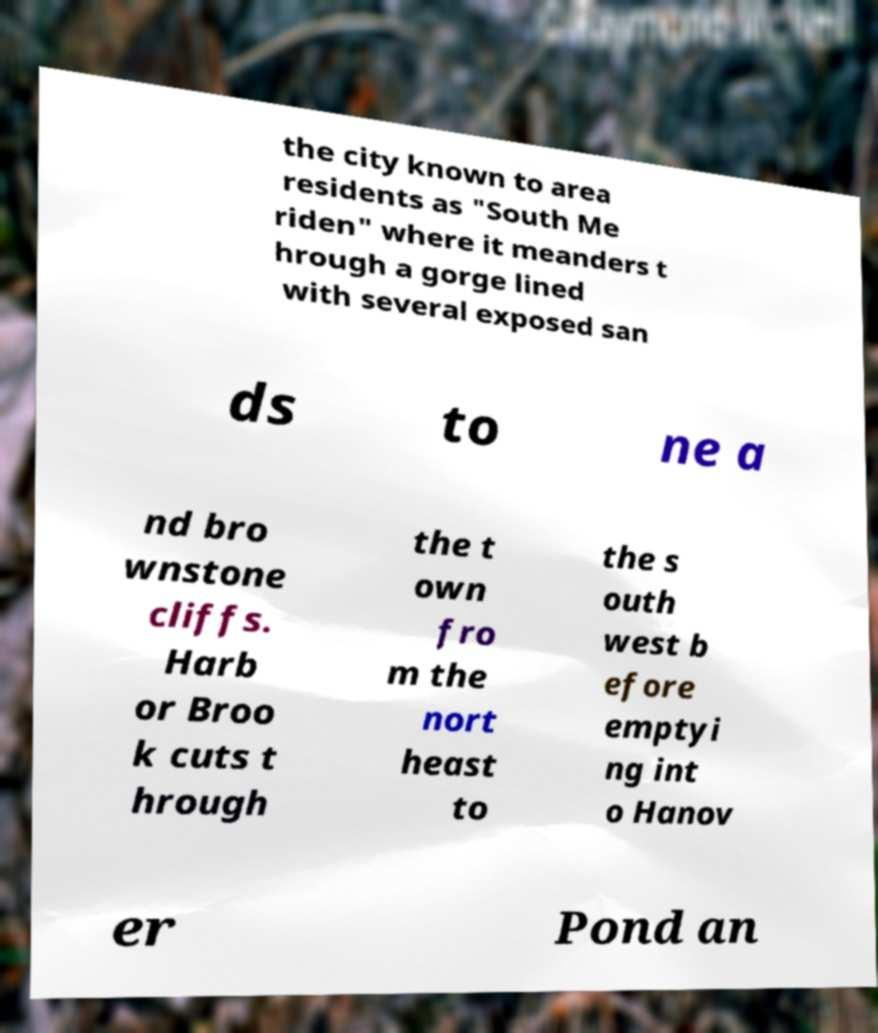Could you extract and type out the text from this image? the city known to area residents as "South Me riden" where it meanders t hrough a gorge lined with several exposed san ds to ne a nd bro wnstone cliffs. Harb or Broo k cuts t hrough the t own fro m the nort heast to the s outh west b efore emptyi ng int o Hanov er Pond an 